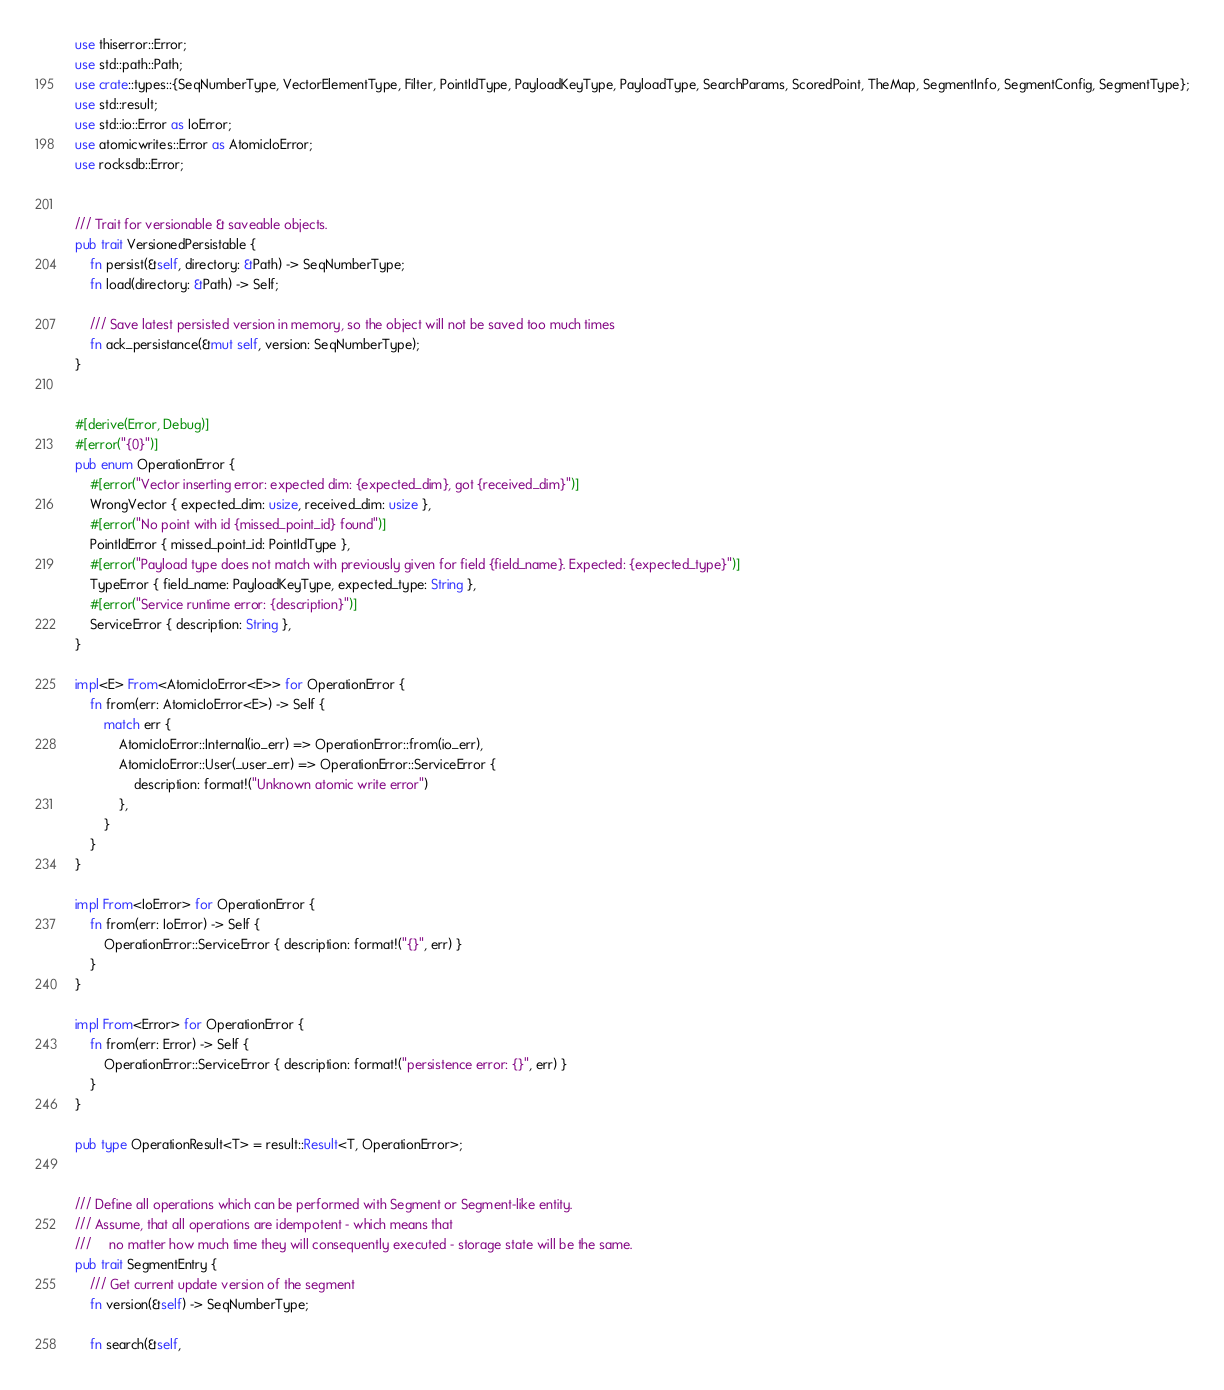Convert code to text. <code><loc_0><loc_0><loc_500><loc_500><_Rust_>use thiserror::Error;
use std::path::Path;
use crate::types::{SeqNumberType, VectorElementType, Filter, PointIdType, PayloadKeyType, PayloadType, SearchParams, ScoredPoint, TheMap, SegmentInfo, SegmentConfig, SegmentType};
use std::result;
use std::io::Error as IoError;
use atomicwrites::Error as AtomicIoError;
use rocksdb::Error;


/// Trait for versionable & saveable objects.
pub trait VersionedPersistable {
    fn persist(&self, directory: &Path) -> SeqNumberType;
    fn load(directory: &Path) -> Self;

    /// Save latest persisted version in memory, so the object will not be saved too much times
    fn ack_persistance(&mut self, version: SeqNumberType);
}


#[derive(Error, Debug)]
#[error("{0}")]
pub enum OperationError {
    #[error("Vector inserting error: expected dim: {expected_dim}, got {received_dim}")]
    WrongVector { expected_dim: usize, received_dim: usize },
    #[error("No point with id {missed_point_id} found")]
    PointIdError { missed_point_id: PointIdType },
    #[error("Payload type does not match with previously given for field {field_name}. Expected: {expected_type}")]
    TypeError { field_name: PayloadKeyType, expected_type: String },
    #[error("Service runtime error: {description}")]
    ServiceError { description: String },
}

impl<E> From<AtomicIoError<E>> for OperationError {
    fn from(err: AtomicIoError<E>) -> Self {
        match err {
            AtomicIoError::Internal(io_err) => OperationError::from(io_err),
            AtomicIoError::User(_user_err) => OperationError::ServiceError {
                description: format!("Unknown atomic write error")
            },
        }
    }
}

impl From<IoError> for OperationError {
    fn from(err: IoError) -> Self {
        OperationError::ServiceError { description: format!("{}", err) }
    }
}

impl From<Error> for OperationError {
    fn from(err: Error) -> Self {
        OperationError::ServiceError { description: format!("persistence error: {}", err) }
    }
}

pub type OperationResult<T> = result::Result<T, OperationError>;


/// Define all operations which can be performed with Segment or Segment-like entity.
/// Assume, that all operations are idempotent - which means that
///     no matter how much time they will consequently executed - storage state will be the same.
pub trait SegmentEntry {
    /// Get current update version of the segment
    fn version(&self) -> SeqNumberType;

    fn search(&self,</code> 